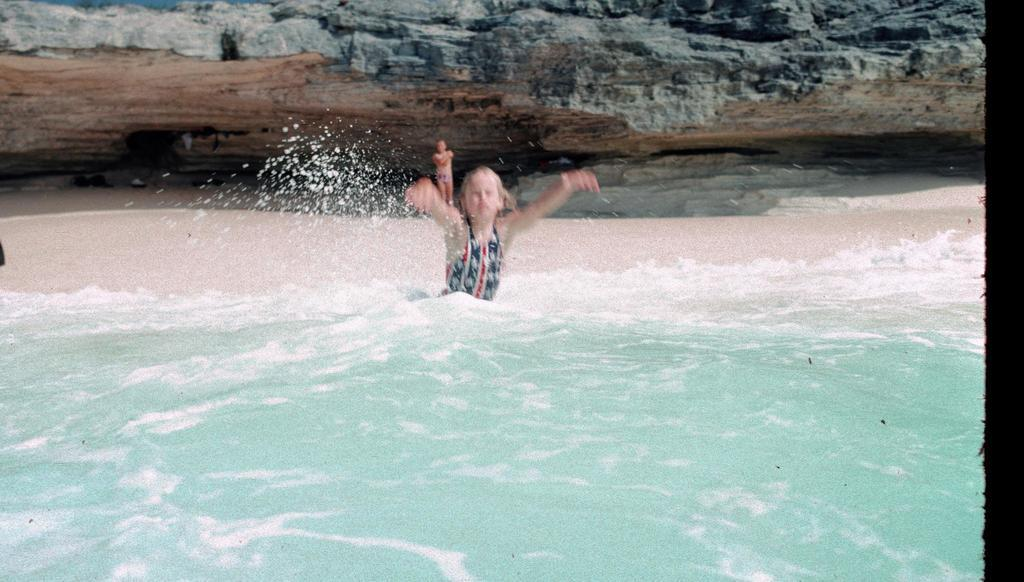What is in the foreground of the image? There is a water body in the foreground of the image. Where is the person located in the image? The person is in the center of the image. What can be seen in the background of the image? There is sand and a rock in the background of the image. Are there any other people visible in the image? Yes, there is another person standing in the background of the image. What page of the book is the person reading in the image? There is no book or reading activity depicted in the image. How many levels of the crowd can be seen in the image? There is no crowd present in the image; it features a person in the center and another person in the background. 